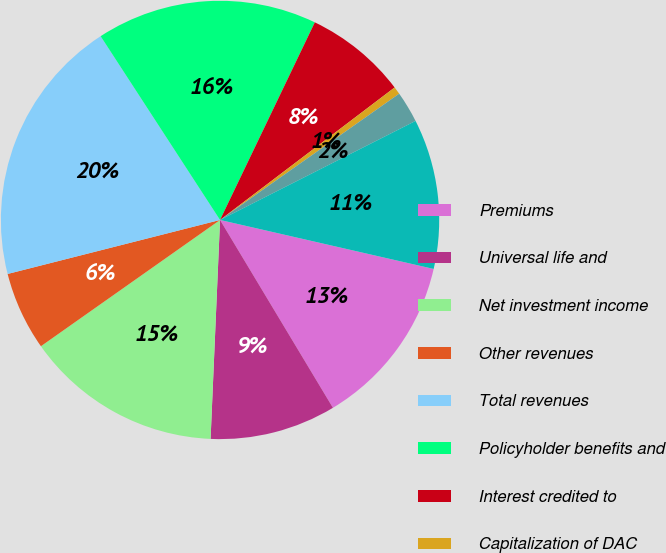Convert chart to OTSL. <chart><loc_0><loc_0><loc_500><loc_500><pie_chart><fcel>Premiums<fcel>Universal life and<fcel>Net investment income<fcel>Other revenues<fcel>Total revenues<fcel>Policyholder benefits and<fcel>Interest credited to<fcel>Capitalization of DAC<fcel>Amortization of DAC and VOBA<fcel>Other expenses<nl><fcel>12.8%<fcel>9.3%<fcel>14.54%<fcel>5.81%<fcel>19.79%<fcel>16.29%<fcel>7.55%<fcel>0.56%<fcel>2.31%<fcel>11.05%<nl></chart> 